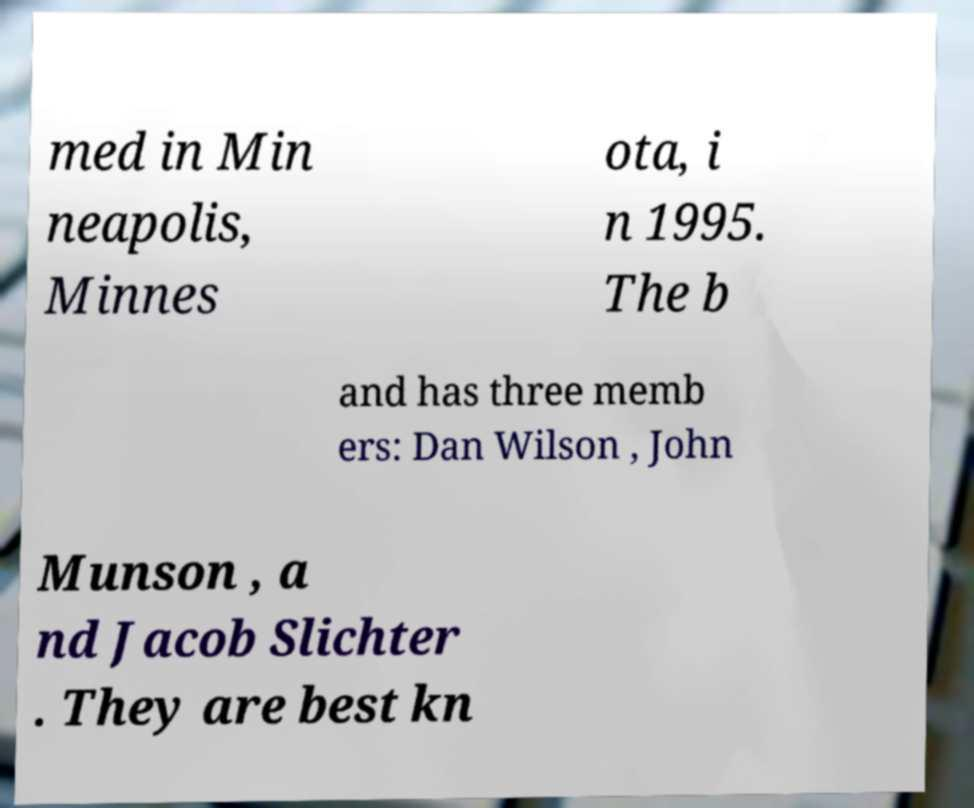Please read and relay the text visible in this image. What does it say? med in Min neapolis, Minnes ota, i n 1995. The b and has three memb ers: Dan Wilson , John Munson , a nd Jacob Slichter . They are best kn 